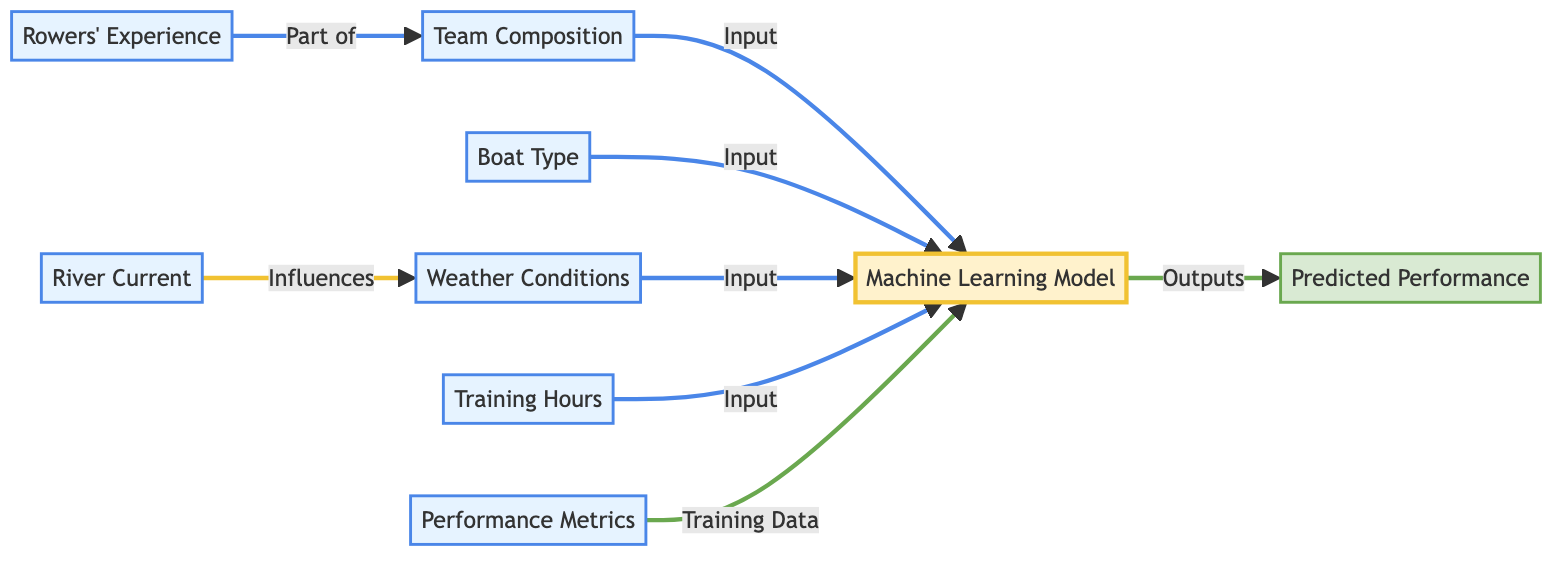What are the inputs to the Machine Learning model? The inputs to the Machine Learning model include Team Composition, Boat Type, Weather Conditions, Training Hours, Rowers' Experience, and River Current. Each of these inputs is represented as a directed edge flowing into the Machine Learning Model node.
Answer: Team Composition, Boat Type, Weather Conditions, Training Hours, Rowers' Experience, River Current How many input nodes are there in the diagram? By counting the individual nodes designated as inputs, we find there are six input nodes: Team Composition, Rowers' Experience, Boat Type, Weather Conditions, River Current, and Training Hours.
Answer: Six What is the relationship between Rowers' Experience and Team Composition? The relationship indicated in the diagram describes Rowers' Experience as part of Team Composition, implying that the experience of rowers contributes to the overall composition of the team.
Answer: Part of What is the output of the Machine Learning model? The output of the Machine Learning model is the Predicted Performance, which is the result generated by analyzing the various inputs fed into it.
Answer: Predicted Performance How does the River Current affect the Weather Conditions? The diagram shows a directed edge indicating that River Current influences Weather Conditions, suggesting that the state of the river can have an impact on the weather factors for a race.
Answer: Influences Which nodes serve as inputs for the Performance Metrics during training? Performance Metrics serves as a training data input for the Machine Learning model. This indicates its role in guiding the model’s learning phase but does not directly influence the prediction output.
Answer: Training Data Which input node does not have a direct connection from another input node? Weather Conditions does not have a direct connection from another input node in the diagram; it is solely an input to the Machine Learning model.
Answer: Weather Conditions What connects the Machine Learning Model to the outputs? The connection from the Machine Learning Model to the outputs in the diagram is represented by the edge flowing to the Predicted Performance node, indicating that the model's computation leads directly to the prediction.
Answer: Outputs How many total nodes are present in the diagram? The total number of nodes in the diagram is eight, which includes six input nodes, one model node, and one output node.
Answer: Eight 